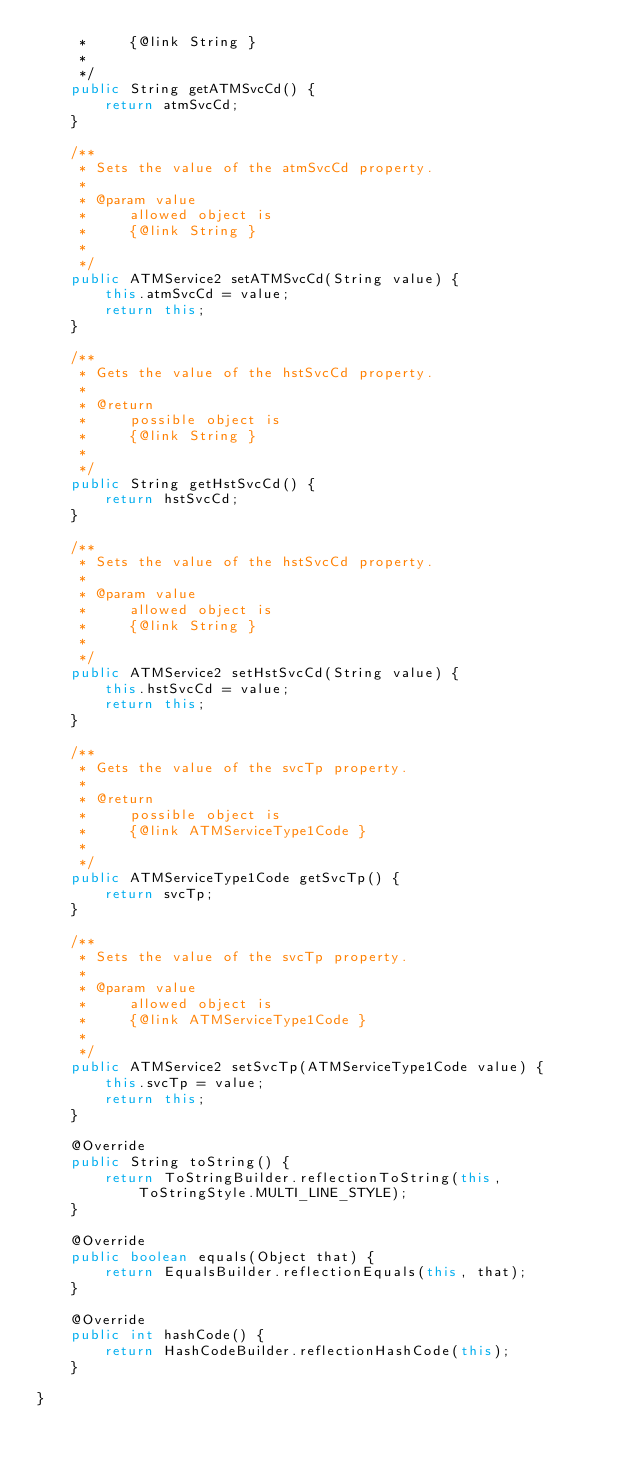<code> <loc_0><loc_0><loc_500><loc_500><_Java_>     *     {@link String }
     *     
     */
    public String getATMSvcCd() {
        return atmSvcCd;
    }

    /**
     * Sets the value of the atmSvcCd property.
     * 
     * @param value
     *     allowed object is
     *     {@link String }
     *     
     */
    public ATMService2 setATMSvcCd(String value) {
        this.atmSvcCd = value;
        return this;
    }

    /**
     * Gets the value of the hstSvcCd property.
     * 
     * @return
     *     possible object is
     *     {@link String }
     *     
     */
    public String getHstSvcCd() {
        return hstSvcCd;
    }

    /**
     * Sets the value of the hstSvcCd property.
     * 
     * @param value
     *     allowed object is
     *     {@link String }
     *     
     */
    public ATMService2 setHstSvcCd(String value) {
        this.hstSvcCd = value;
        return this;
    }

    /**
     * Gets the value of the svcTp property.
     * 
     * @return
     *     possible object is
     *     {@link ATMServiceType1Code }
     *     
     */
    public ATMServiceType1Code getSvcTp() {
        return svcTp;
    }

    /**
     * Sets the value of the svcTp property.
     * 
     * @param value
     *     allowed object is
     *     {@link ATMServiceType1Code }
     *     
     */
    public ATMService2 setSvcTp(ATMServiceType1Code value) {
        this.svcTp = value;
        return this;
    }

    @Override
    public String toString() {
        return ToStringBuilder.reflectionToString(this, ToStringStyle.MULTI_LINE_STYLE);
    }

    @Override
    public boolean equals(Object that) {
        return EqualsBuilder.reflectionEquals(this, that);
    }

    @Override
    public int hashCode() {
        return HashCodeBuilder.reflectionHashCode(this);
    }

}
</code> 